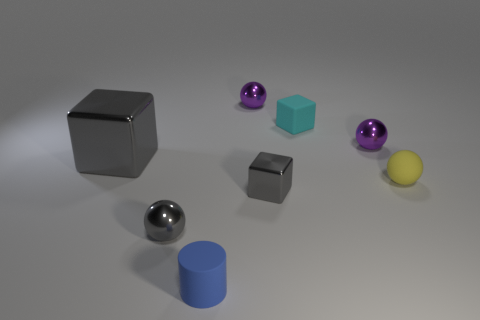Add 2 tiny balls. How many objects exist? 10 Subtract all cylinders. How many objects are left? 7 Subtract 1 gray cubes. How many objects are left? 7 Subtract all cylinders. Subtract all tiny blue rubber objects. How many objects are left? 6 Add 5 metallic things. How many metallic things are left? 10 Add 3 large blue cubes. How many large blue cubes exist? 3 